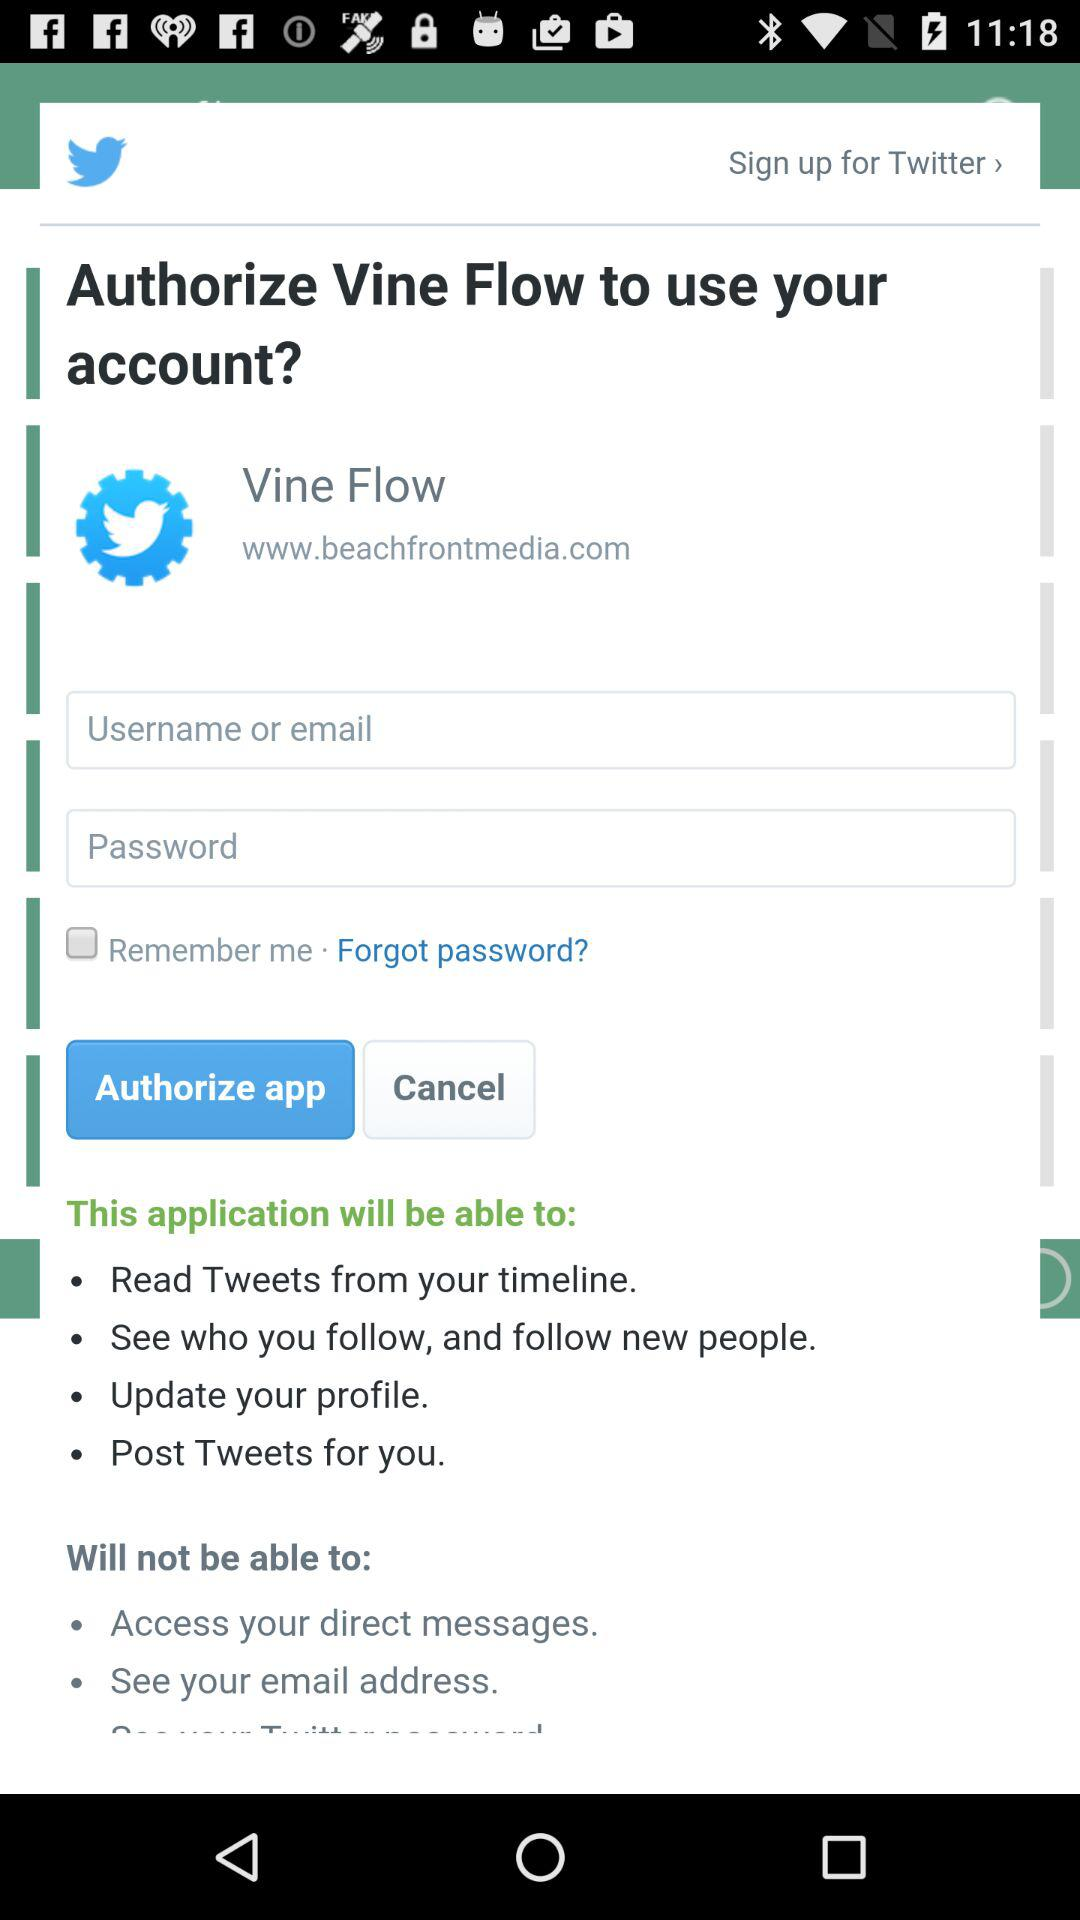How many input fields are required to authorize Vine Flow?
Answer the question using a single word or phrase. 2 